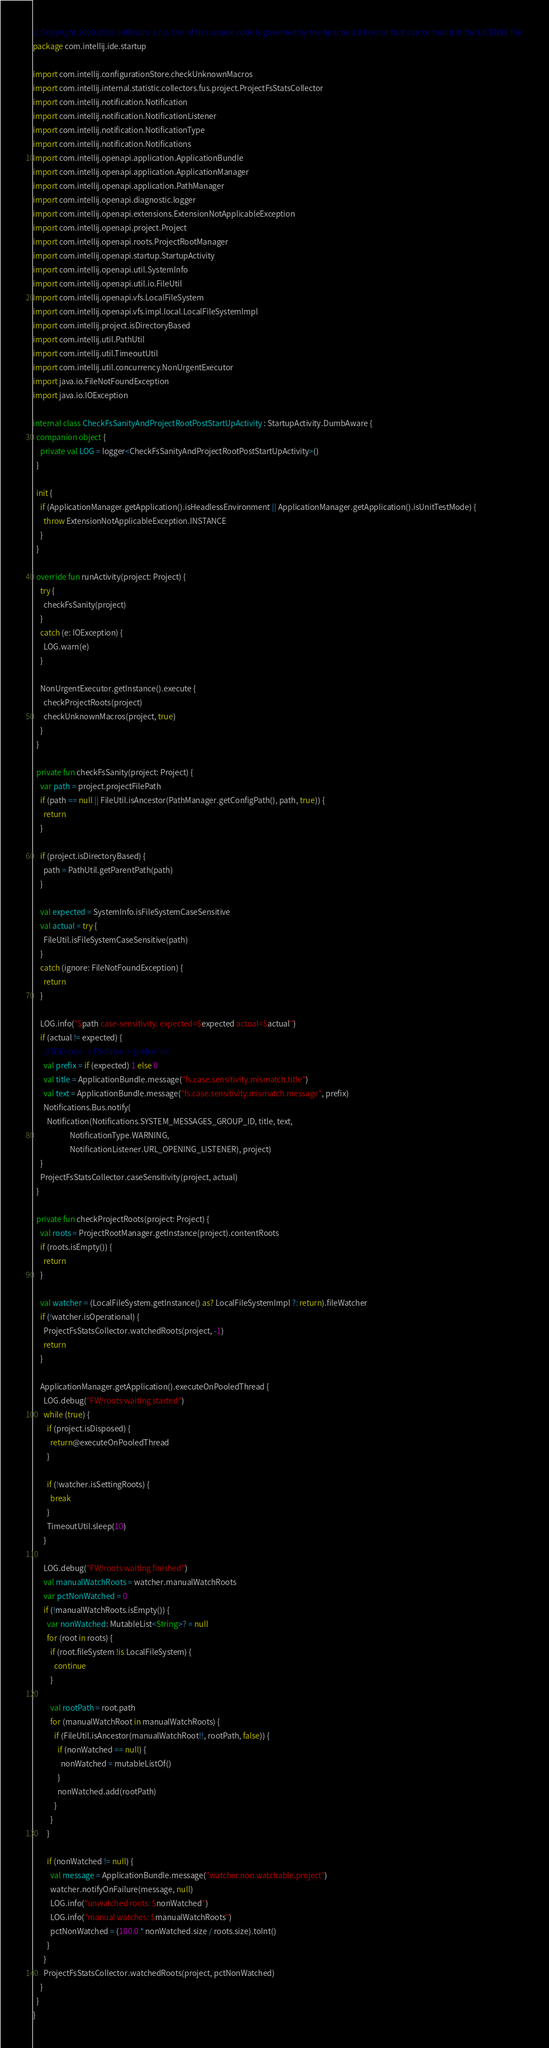<code> <loc_0><loc_0><loc_500><loc_500><_Kotlin_>// Copyright 2000-2019 JetBrains s.r.o. Use of this source code is governed by the Apache 2.0 license that can be found in the LICENSE file.
package com.intellij.ide.startup

import com.intellij.configurationStore.checkUnknownMacros
import com.intellij.internal.statistic.collectors.fus.project.ProjectFsStatsCollector
import com.intellij.notification.Notification
import com.intellij.notification.NotificationListener
import com.intellij.notification.NotificationType
import com.intellij.notification.Notifications
import com.intellij.openapi.application.ApplicationBundle
import com.intellij.openapi.application.ApplicationManager
import com.intellij.openapi.application.PathManager
import com.intellij.openapi.diagnostic.logger
import com.intellij.openapi.extensions.ExtensionNotApplicableException
import com.intellij.openapi.project.Project
import com.intellij.openapi.roots.ProjectRootManager
import com.intellij.openapi.startup.StartupActivity
import com.intellij.openapi.util.SystemInfo
import com.intellij.openapi.util.io.FileUtil
import com.intellij.openapi.vfs.LocalFileSystem
import com.intellij.openapi.vfs.impl.local.LocalFileSystemImpl
import com.intellij.project.isDirectoryBased
import com.intellij.util.PathUtil
import com.intellij.util.TimeoutUtil
import com.intellij.util.concurrency.NonUrgentExecutor
import java.io.FileNotFoundException
import java.io.IOException

internal class CheckFsSanityAndProjectRootPostStartUpActivity : StartupActivity.DumbAware {
  companion object {
    private val LOG = logger<CheckFsSanityAndProjectRootPostStartUpActivity>()
  }

  init {
    if (ApplicationManager.getApplication().isHeadlessEnvironment || ApplicationManager.getApplication().isUnitTestMode) {
      throw ExtensionNotApplicableException.INSTANCE
    }
  }

  override fun runActivity(project: Project) {
    try {
      checkFsSanity(project)
    }
    catch (e: IOException) {
      LOG.warn(e)
    }

    NonUrgentExecutor.getInstance().execute {
      checkProjectRoots(project)
      checkUnknownMacros(project, true)
    }
  }

  private fun checkFsSanity(project: Project) {
    var path = project.projectFilePath
    if (path == null || FileUtil.isAncestor(PathManager.getConfigPath(), path, true)) {
      return
    }

    if (project.isDirectoryBased) {
      path = PathUtil.getParentPath(path)
    }

    val expected = SystemInfo.isFileSystemCaseSensitive
    val actual = try {
      FileUtil.isFileSystemCaseSensitive(path)
    }
    catch (ignore: FileNotFoundException) {
      return
    }

    LOG.info("$path case-sensitivity: expected=$expected actual=$actual")
    if (actual != expected) {
      // IDE=true -> FS=false -> prefix='in'
      val prefix = if (expected) 1 else 0
      val title = ApplicationBundle.message("fs.case.sensitivity.mismatch.title")
      val text = ApplicationBundle.message("fs.case.sensitivity.mismatch.message", prefix)
      Notifications.Bus.notify(
        Notification(Notifications.SYSTEM_MESSAGES_GROUP_ID, title, text,
                     NotificationType.WARNING,
                     NotificationListener.URL_OPENING_LISTENER), project)
    }
    ProjectFsStatsCollector.caseSensitivity(project, actual)
  }

  private fun checkProjectRoots(project: Project) {
    val roots = ProjectRootManager.getInstance(project).contentRoots
    if (roots.isEmpty()) {
      return
    }

    val watcher = (LocalFileSystem.getInstance() as? LocalFileSystemImpl ?: return).fileWatcher
    if (!watcher.isOperational) {
      ProjectFsStatsCollector.watchedRoots(project, -1)
      return
    }

    ApplicationManager.getApplication().executeOnPooledThread {
      LOG.debug("FW/roots waiting started")
      while (true) {
        if (project.isDisposed) {
          return@executeOnPooledThread
        }

        if (!watcher.isSettingRoots) {
          break
        }
        TimeoutUtil.sleep(10)
      }

      LOG.debug("FW/roots waiting finished")
      val manualWatchRoots = watcher.manualWatchRoots
      var pctNonWatched = 0
      if (!manualWatchRoots.isEmpty()) {
        var nonWatched: MutableList<String>? = null
        for (root in roots) {
          if (root.fileSystem !is LocalFileSystem) {
            continue
          }

          val rootPath = root.path
          for (manualWatchRoot in manualWatchRoots) {
            if (FileUtil.isAncestor(manualWatchRoot!!, rootPath, false)) {
              if (nonWatched == null) {
                nonWatched = mutableListOf()
              }
              nonWatched.add(rootPath)
            }
          }
        }

        if (nonWatched != null) {
          val message = ApplicationBundle.message("watcher.non.watchable.project")
          watcher.notifyOnFailure(message, null)
          LOG.info("unwatched roots: $nonWatched")
          LOG.info("manual watches: $manualWatchRoots")
          pctNonWatched = (100.0 * nonWatched.size / roots.size).toInt()
        }
      }
      ProjectFsStatsCollector.watchedRoots(project, pctNonWatched)
    }
  }
}
</code> 